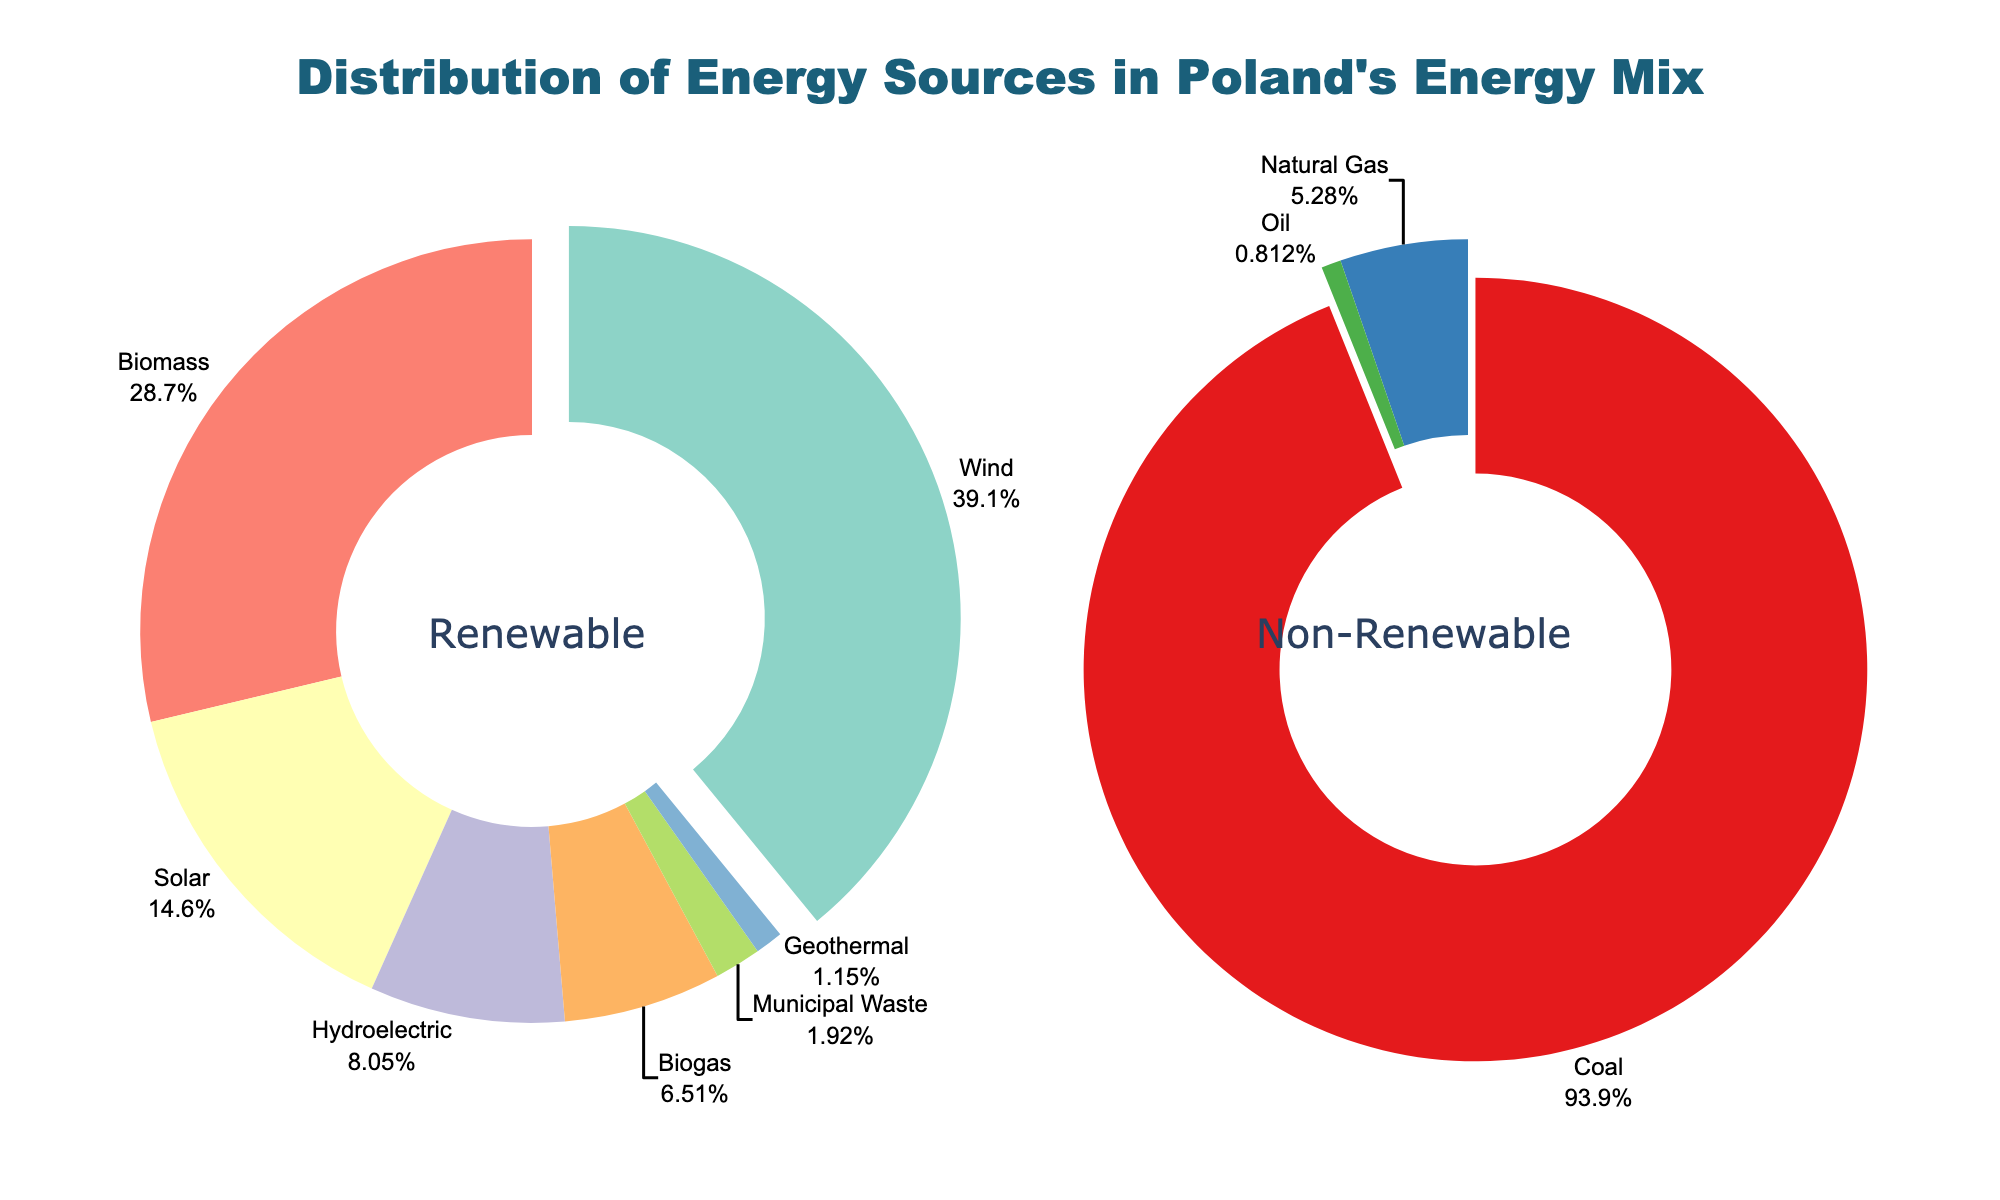What percentage of Poland's energy mix comes from renewable sources? The total percentage of renewable sources is the sum of the individual percentages for Wind, Solar, Hydroelectric, Biomass, Geothermal, Biogas, and Municipal Waste. Adding these values together (10.2 + 3.8 + 2.1 + 7.5 + 0.3 + 1.7 + 0.5) = 26.1%.
Answer: 26.1% What is the largest source of energy in Poland's renewable energy mix? By referring to the relevant pie chart segment sizes, Wind (10.2%) is the largest source in the renewable category.
Answer: Wind How does the percentage of coal in Poland's energy mix compare to the combined total of all renewable sources? The percentage for coal is 69.4%, whereas the combined total for all renewable sources is 26.1%. Comparing these, coal (69.4%) is much greater than the total of renewable sources (26.1%).
Answer: Coal is much greater How much higher is the percentage of wind energy compared to solar energy? The percentage for wind is 10.2%, and for solar, it is 3.8%. The difference is calculated as (10.2% - 3.8%) = 6.4%.
Answer: 6.4% Which non-renewable energy source is slightly higher than one of the renewable sources? Observing the percentages, Natural Gas at 3.9% is slightly higher than Solar at 3.8%.
Answer: Natural Gas Which energy source contributes less than 1% to Poland's energy mix? From the pie chart, the sources that contribute less than 1% are Geothermal (0.3%), Biogas (0.5%), and Municipal Waste (0.5%).
Answer: Geothermal, Biogas, Municipal Waste By how much does the percentage of biomass energy exceed the percentage of biogas energy? The percentage for Biomass is 7.5%, and for Biogas, it is 1.7%. The difference is calculated as (7.5% - 1.7%) = 5.8%.
Answer: 5.8% What is the total percentage of non-renewable energy sources? The total percentage of non-renewable sources is the sum of the individual percentages for Coal, Natural Gas, and Oil. Adding these values together (69.4 + 3.9 + 0.6) = 73.9%.
Answer: 73.9% Which segment in the renewable pie chart is pulled out from the rest? The pie chart pulls out the segment of the largest source, which is Wind at 10.2%. Therefore, Wind is the segment pulled out.
Answer: Wind 